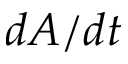Convert formula to latex. <formula><loc_0><loc_0><loc_500><loc_500>d A / d t</formula> 